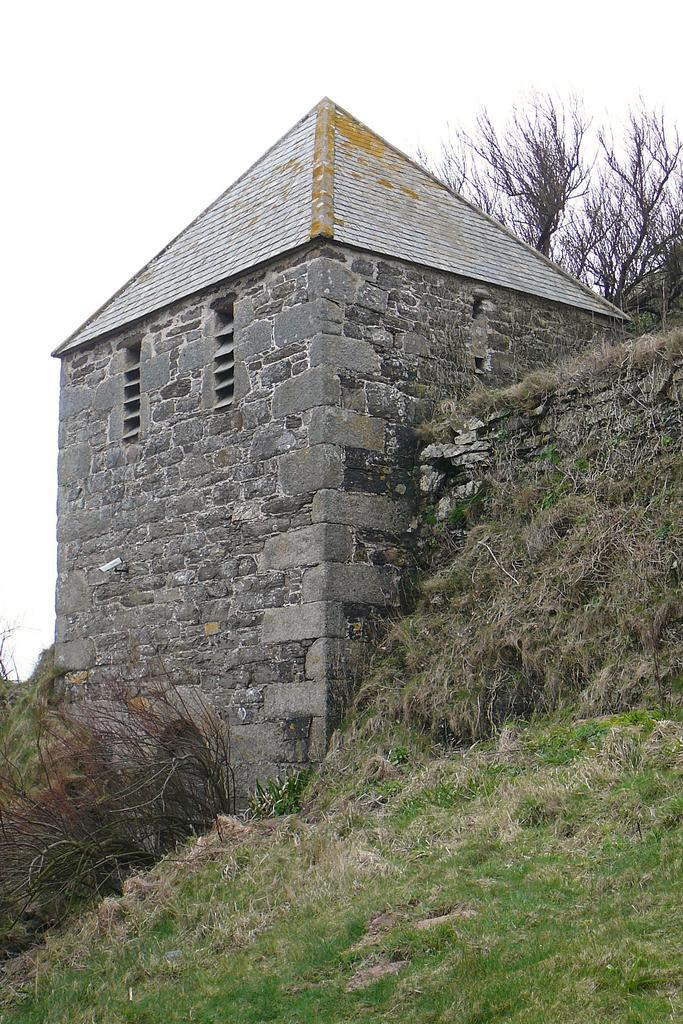What type of building is in the image? There is a building with a brick wall in the image. Does the building have any specific features? Yes, the building has ventilation. What is on the ground in the image? There is grass and plants on the ground in the image. What can be seen in the background of the image? There are trees and the sky visible in the background of the image. Where is the yam being stored in the image? There is no yam present in the image. What type of mailbox can be seen near the building in the image? There is no mailbox visible in the image. 